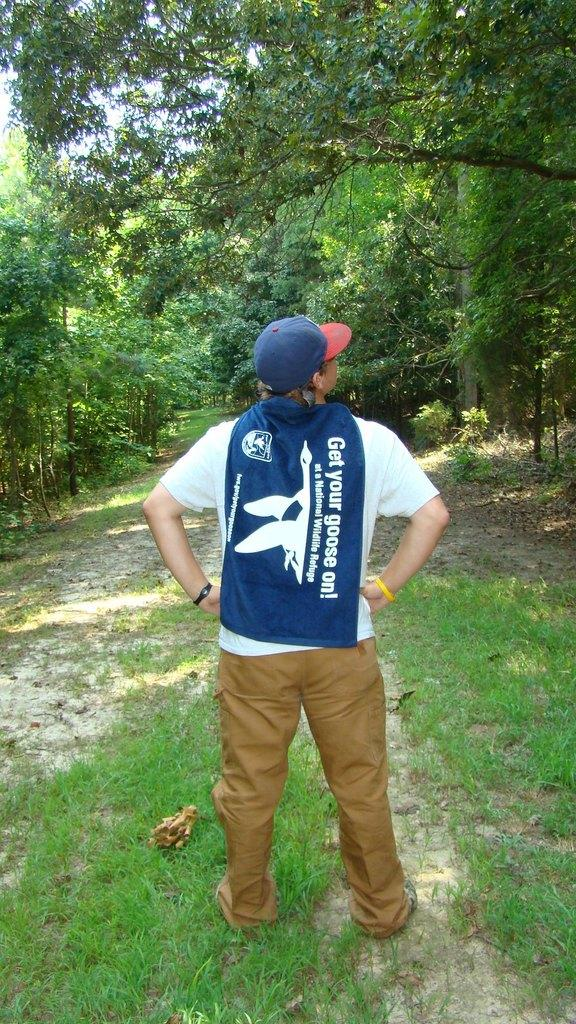<image>
Provide a brief description of the given image. The top this man is wearing says get your goose on. 